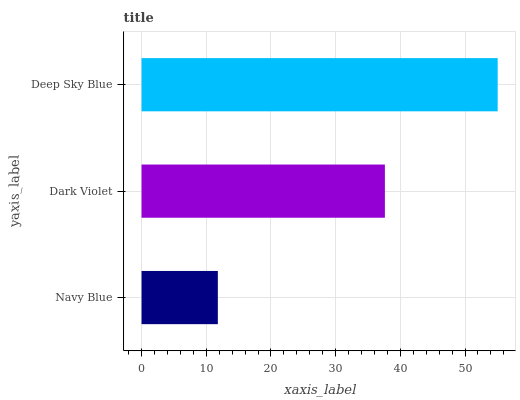Is Navy Blue the minimum?
Answer yes or no. Yes. Is Deep Sky Blue the maximum?
Answer yes or no. Yes. Is Dark Violet the minimum?
Answer yes or no. No. Is Dark Violet the maximum?
Answer yes or no. No. Is Dark Violet greater than Navy Blue?
Answer yes or no. Yes. Is Navy Blue less than Dark Violet?
Answer yes or no. Yes. Is Navy Blue greater than Dark Violet?
Answer yes or no. No. Is Dark Violet less than Navy Blue?
Answer yes or no. No. Is Dark Violet the high median?
Answer yes or no. Yes. Is Dark Violet the low median?
Answer yes or no. Yes. Is Deep Sky Blue the high median?
Answer yes or no. No. Is Navy Blue the low median?
Answer yes or no. No. 